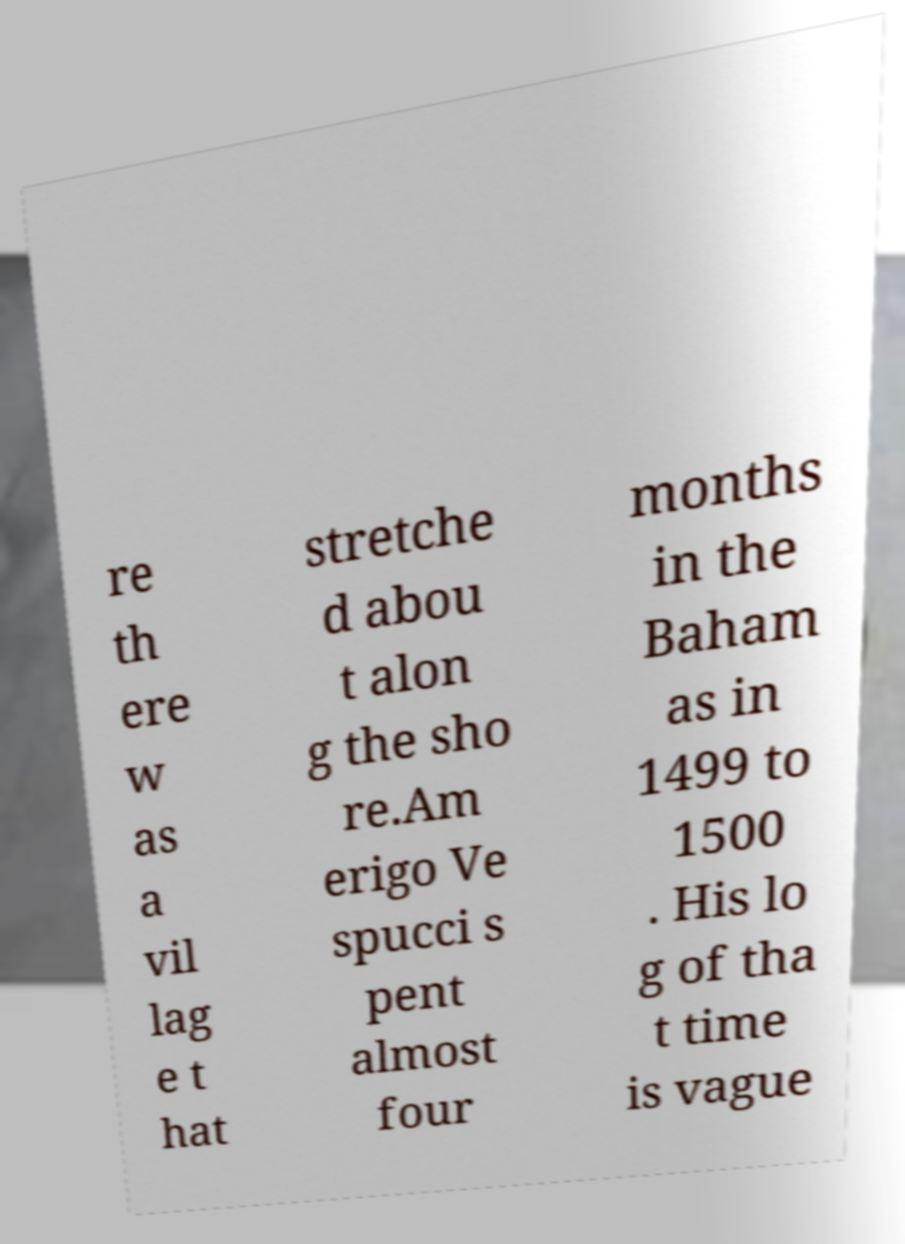Can you read and provide the text displayed in the image?This photo seems to have some interesting text. Can you extract and type it out for me? re th ere w as a vil lag e t hat stretche d abou t alon g the sho re.Am erigo Ve spucci s pent almost four months in the Baham as in 1499 to 1500 . His lo g of tha t time is vague 